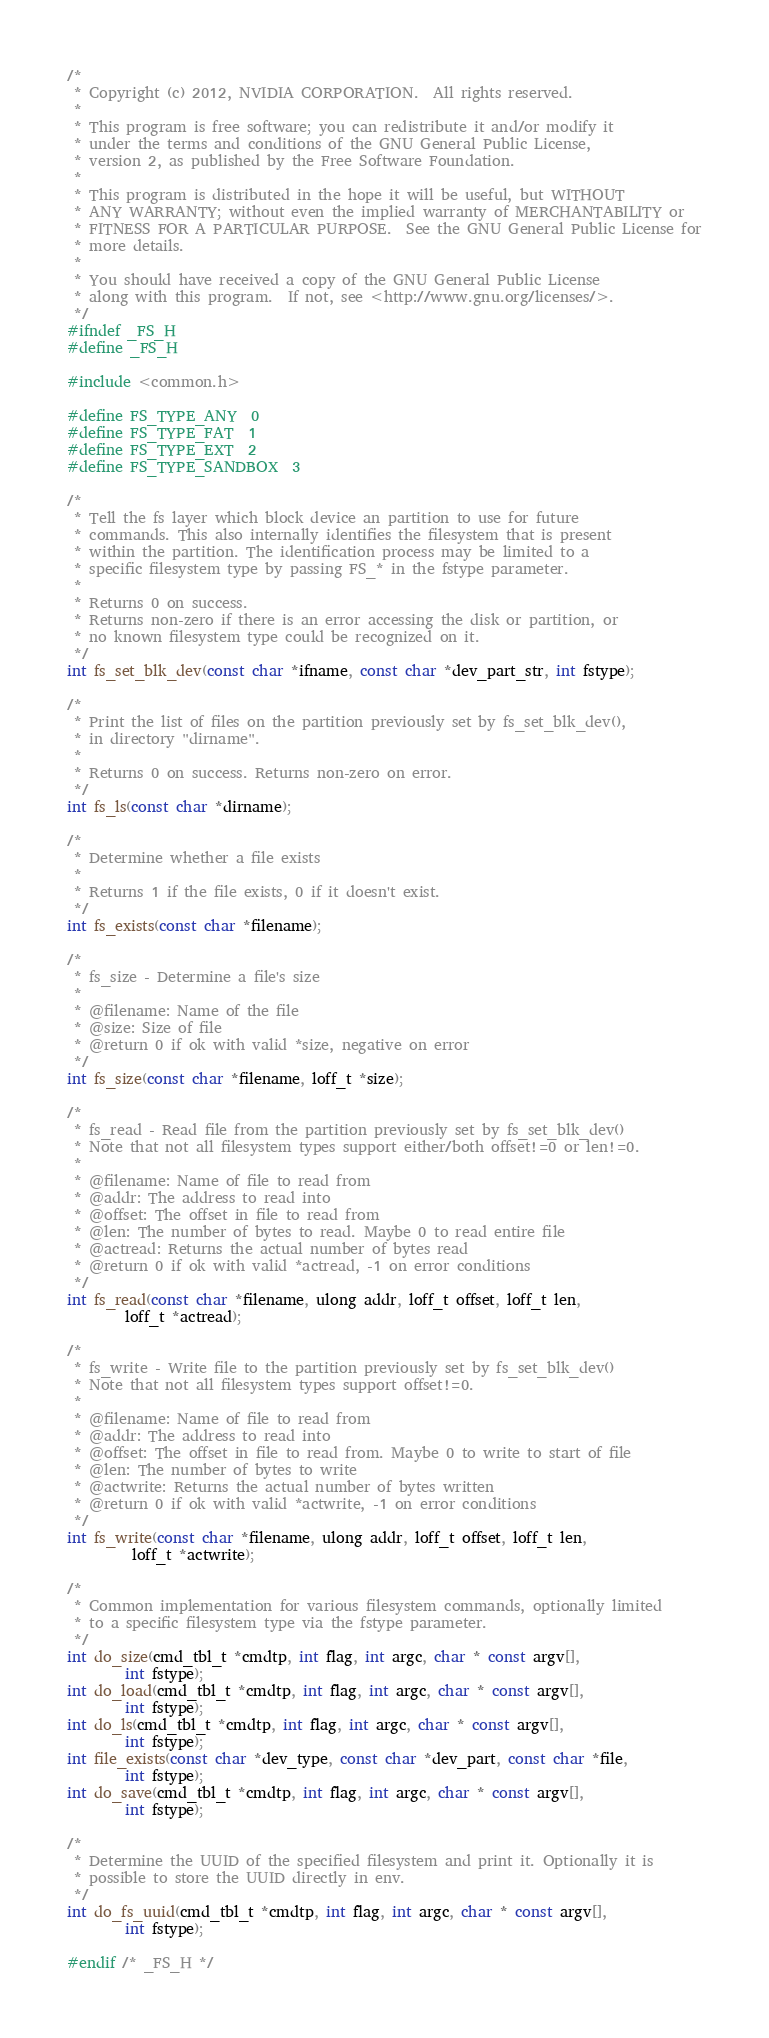Convert code to text. <code><loc_0><loc_0><loc_500><loc_500><_C_>/*
 * Copyright (c) 2012, NVIDIA CORPORATION.  All rights reserved.
 *
 * This program is free software; you can redistribute it and/or modify it
 * under the terms and conditions of the GNU General Public License,
 * version 2, as published by the Free Software Foundation.
 *
 * This program is distributed in the hope it will be useful, but WITHOUT
 * ANY WARRANTY; without even the implied warranty of MERCHANTABILITY or
 * FITNESS FOR A PARTICULAR PURPOSE.  See the GNU General Public License for
 * more details.
 *
 * You should have received a copy of the GNU General Public License
 * along with this program.  If not, see <http://www.gnu.org/licenses/>.
 */
#ifndef _FS_H
#define _FS_H

#include <common.h>

#define FS_TYPE_ANY	0
#define FS_TYPE_FAT	1
#define FS_TYPE_EXT	2
#define FS_TYPE_SANDBOX	3

/*
 * Tell the fs layer which block device an partition to use for future
 * commands. This also internally identifies the filesystem that is present
 * within the partition. The identification process may be limited to a
 * specific filesystem type by passing FS_* in the fstype parameter.
 *
 * Returns 0 on success.
 * Returns non-zero if there is an error accessing the disk or partition, or
 * no known filesystem type could be recognized on it.
 */
int fs_set_blk_dev(const char *ifname, const char *dev_part_str, int fstype);

/*
 * Print the list of files on the partition previously set by fs_set_blk_dev(),
 * in directory "dirname".
 *
 * Returns 0 on success. Returns non-zero on error.
 */
int fs_ls(const char *dirname);

/*
 * Determine whether a file exists
 *
 * Returns 1 if the file exists, 0 if it doesn't exist.
 */
int fs_exists(const char *filename);

/*
 * fs_size - Determine a file's size
 *
 * @filename: Name of the file
 * @size: Size of file
 * @return 0 if ok with valid *size, negative on error
 */
int fs_size(const char *filename, loff_t *size);

/*
 * fs_read - Read file from the partition previously set by fs_set_blk_dev()
 * Note that not all filesystem types support either/both offset!=0 or len!=0.
 *
 * @filename: Name of file to read from
 * @addr: The address to read into
 * @offset: The offset in file to read from
 * @len: The number of bytes to read. Maybe 0 to read entire file
 * @actread: Returns the actual number of bytes read
 * @return 0 if ok with valid *actread, -1 on error conditions
 */
int fs_read(const char *filename, ulong addr, loff_t offset, loff_t len,
	    loff_t *actread);

/*
 * fs_write - Write file to the partition previously set by fs_set_blk_dev()
 * Note that not all filesystem types support offset!=0.
 *
 * @filename: Name of file to read from
 * @addr: The address to read into
 * @offset: The offset in file to read from. Maybe 0 to write to start of file
 * @len: The number of bytes to write
 * @actwrite: Returns the actual number of bytes written
 * @return 0 if ok with valid *actwrite, -1 on error conditions
 */
int fs_write(const char *filename, ulong addr, loff_t offset, loff_t len,
	     loff_t *actwrite);

/*
 * Common implementation for various filesystem commands, optionally limited
 * to a specific filesystem type via the fstype parameter.
 */
int do_size(cmd_tbl_t *cmdtp, int flag, int argc, char * const argv[],
		int fstype);
int do_load(cmd_tbl_t *cmdtp, int flag, int argc, char * const argv[],
		int fstype);
int do_ls(cmd_tbl_t *cmdtp, int flag, int argc, char * const argv[],
		int fstype);
int file_exists(const char *dev_type, const char *dev_part, const char *file,
		int fstype);
int do_save(cmd_tbl_t *cmdtp, int flag, int argc, char * const argv[],
		int fstype);

/*
 * Determine the UUID of the specified filesystem and print it. Optionally it is
 * possible to store the UUID directly in env.
 */
int do_fs_uuid(cmd_tbl_t *cmdtp, int flag, int argc, char * const argv[],
		int fstype);

#endif /* _FS_H */
</code> 